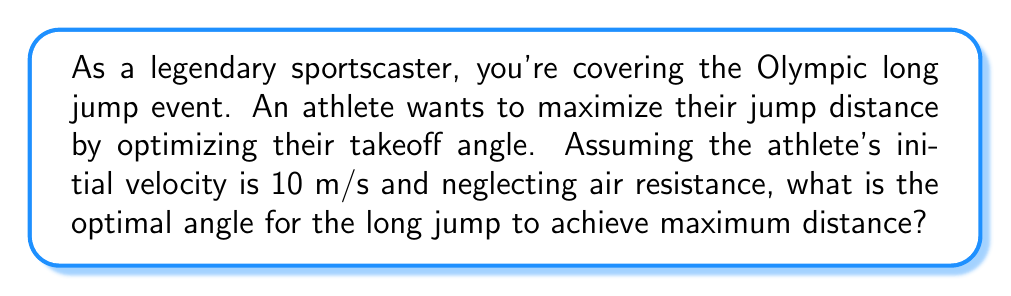Can you answer this question? Let's approach this step-by-step using calculus:

1) The distance of a projectile (like a long jumper) is given by the equation:

   $$d = \frac{v^2 \sin(2\theta)}{g}$$

   Where $d$ is the distance, $v$ is the initial velocity, $\theta$ is the angle of takeoff, and $g$ is the acceleration due to gravity (9.8 m/s²).

2) To find the maximum distance, we need to find the angle $\theta$ that maximizes this function. We can do this by taking the derivative of $d$ with respect to $\theta$ and setting it equal to zero.

3) First, let's simplify our equation by treating $\frac{v^2}{g}$ as a constant $k$:

   $$d = k \sin(2\theta)$$

4) Now, let's take the derivative:

   $$\frac{dd}{d\theta} = 2k \cos(2\theta)$$

5) Set this equal to zero and solve:

   $$2k \cos(2\theta) = 0$$
   $$\cos(2\theta) = 0$$

6) The cosine function equals zero when its argument is $\frac{\pi}{2}$ or $\frac{3\pi}{2}$. So:

   $$2\theta = \frac{\pi}{2}$$
   $$\theta = \frac{\pi}{4} = 45°$$

7) To confirm this is a maximum (not a minimum), we can check the second derivative:

   $$\frac{d^2d}{d\theta^2} = -4k \sin(2\theta)$$

   At $\theta = 45°$, this is negative, confirming a maximum.

Therefore, the optimal angle for the long jump is 45°.
Answer: 45° 